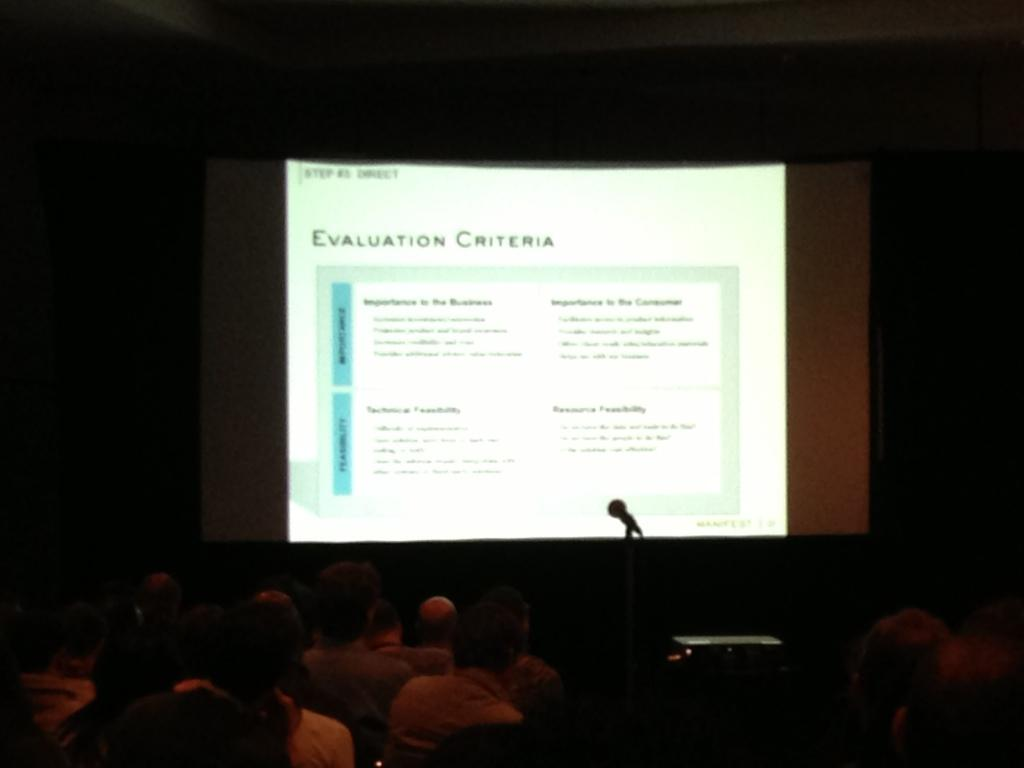What are the persons in the image doing? A: The persons in the image are sitting on chairs. What equipment is present in the image? There is a projector on a stand, a screen, and a mic on a stand in the image. What is the lighting condition in the image? The background of the image is dark. What type of can is being used to teach the class in the image? There is no can present in the image, and no teaching is taking place. Can you see a hen in the image? There is no hen present in the image. 